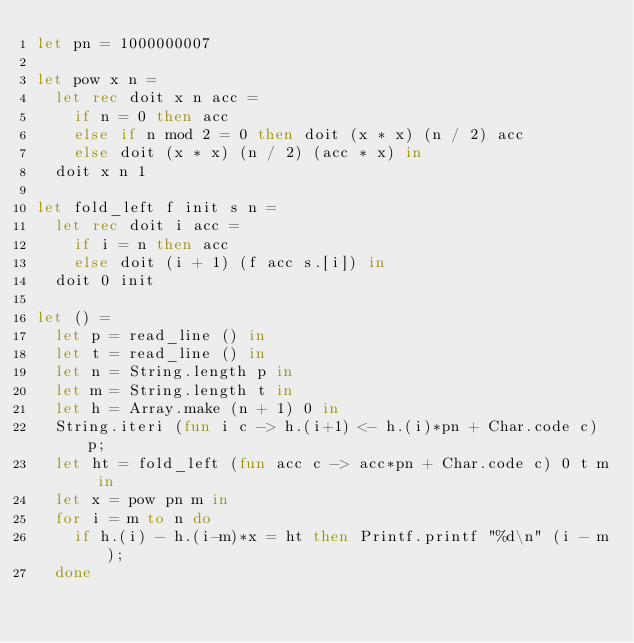Convert code to text. <code><loc_0><loc_0><loc_500><loc_500><_OCaml_>let pn = 1000000007

let pow x n =
  let rec doit x n acc =
    if n = 0 then acc
    else if n mod 2 = 0 then doit (x * x) (n / 2) acc
    else doit (x * x) (n / 2) (acc * x) in
  doit x n 1

let fold_left f init s n =
  let rec doit i acc =
    if i = n then acc
    else doit (i + 1) (f acc s.[i]) in
  doit 0 init

let () =
  let p = read_line () in
  let t = read_line () in
  let n = String.length p in
  let m = String.length t in
  let h = Array.make (n + 1) 0 in
  String.iteri (fun i c -> h.(i+1) <- h.(i)*pn + Char.code c) p;
  let ht = fold_left (fun acc c -> acc*pn + Char.code c) 0 t m in
  let x = pow pn m in
  for i = m to n do
    if h.(i) - h.(i-m)*x = ht then Printf.printf "%d\n" (i - m);
  done</code> 